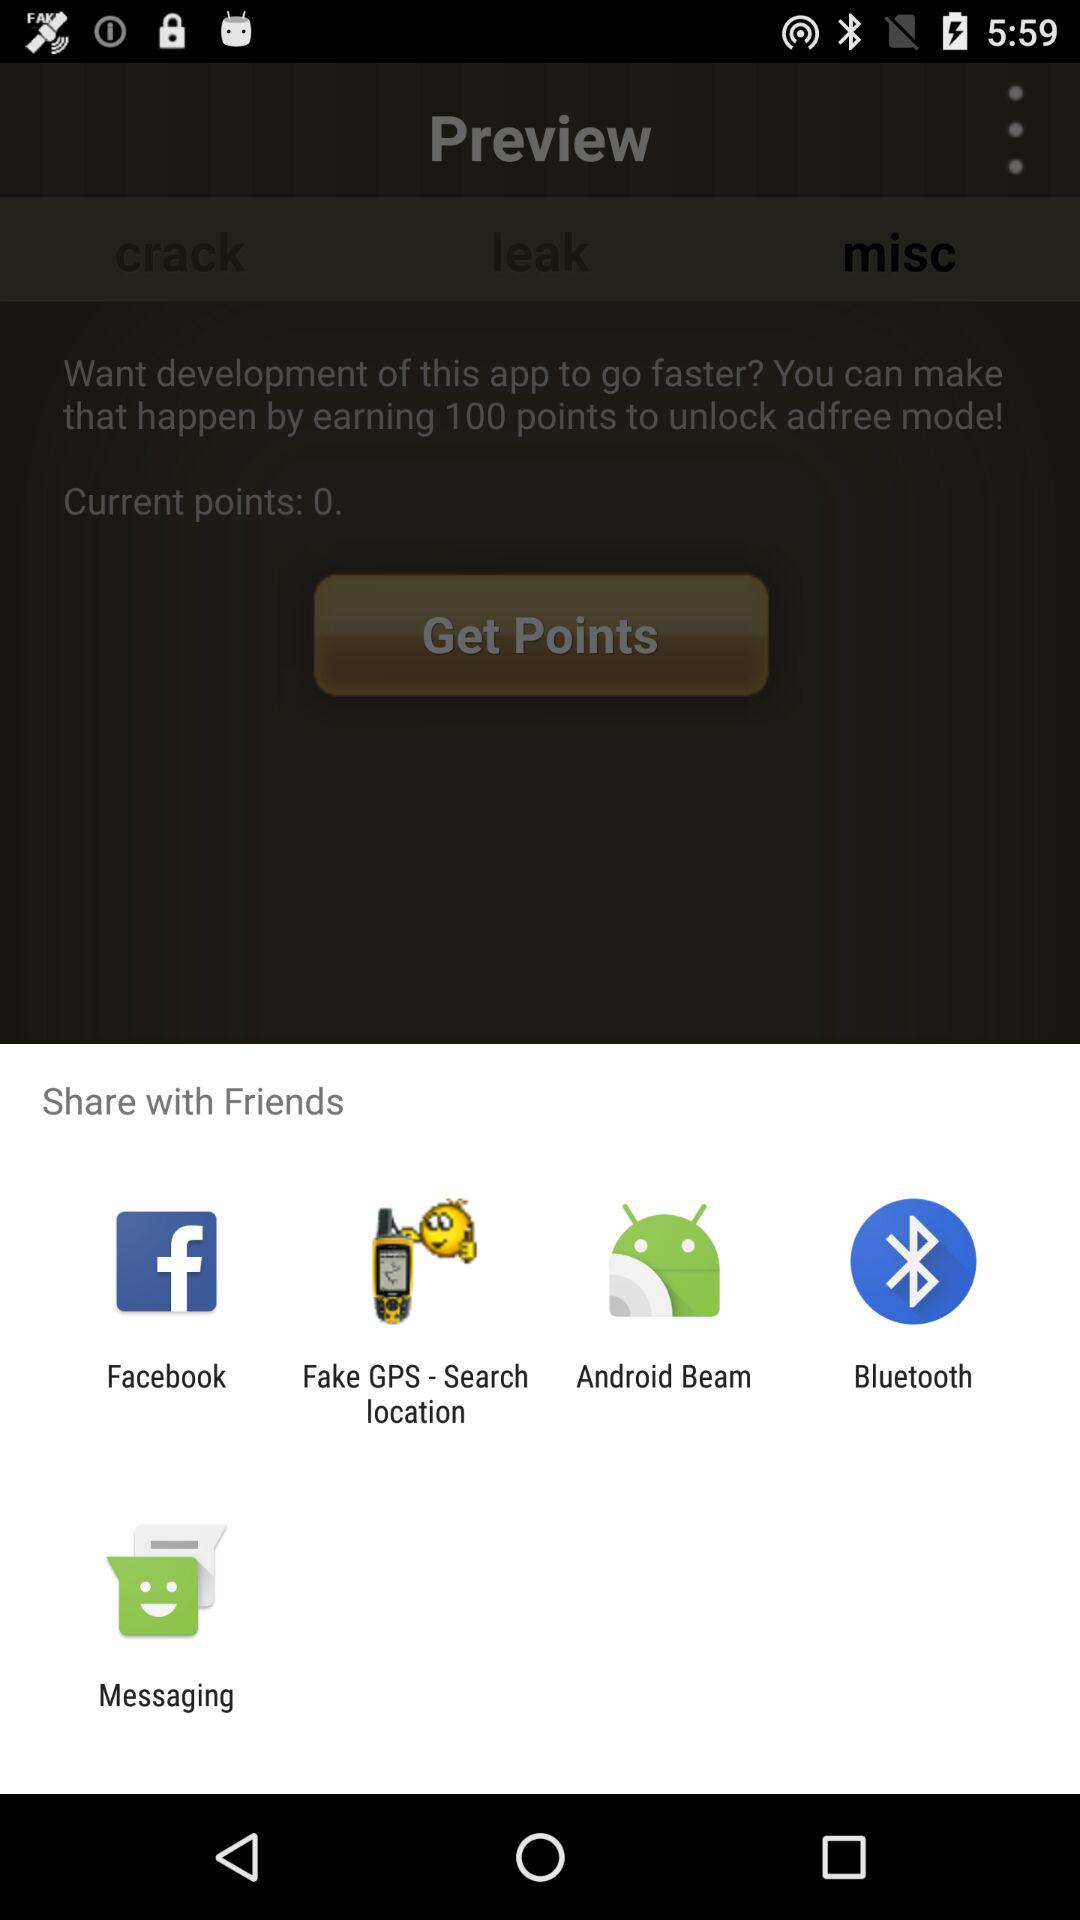What is the number of current points? The number of current points is 0. 